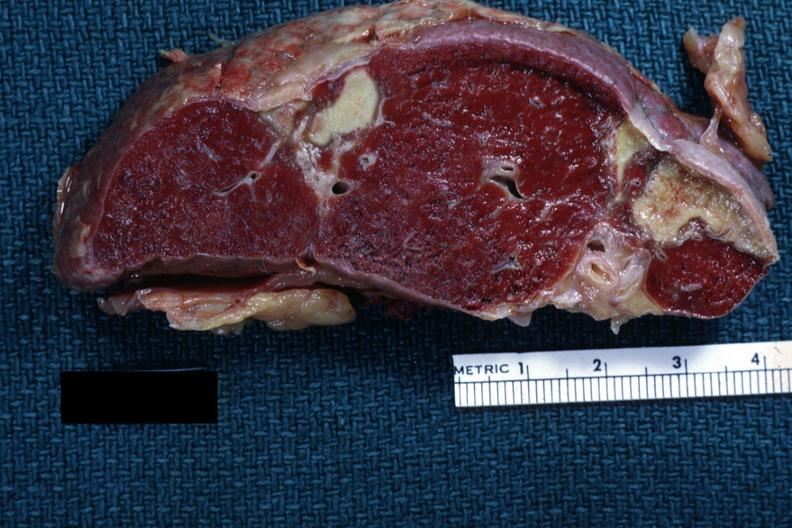s hematologic present?
Answer the question using a single word or phrase. Yes 